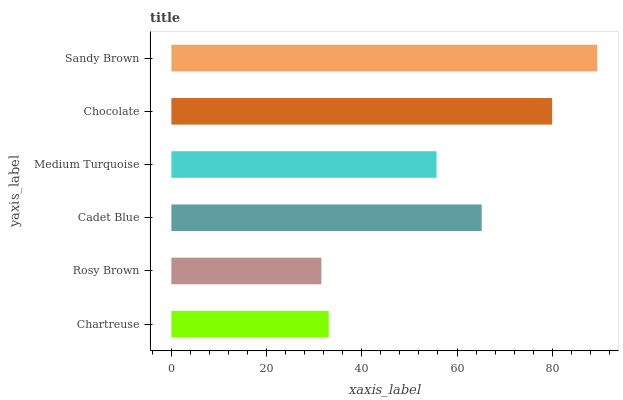Is Rosy Brown the minimum?
Answer yes or no. Yes. Is Sandy Brown the maximum?
Answer yes or no. Yes. Is Cadet Blue the minimum?
Answer yes or no. No. Is Cadet Blue the maximum?
Answer yes or no. No. Is Cadet Blue greater than Rosy Brown?
Answer yes or no. Yes. Is Rosy Brown less than Cadet Blue?
Answer yes or no. Yes. Is Rosy Brown greater than Cadet Blue?
Answer yes or no. No. Is Cadet Blue less than Rosy Brown?
Answer yes or no. No. Is Cadet Blue the high median?
Answer yes or no. Yes. Is Medium Turquoise the low median?
Answer yes or no. Yes. Is Rosy Brown the high median?
Answer yes or no. No. Is Chocolate the low median?
Answer yes or no. No. 